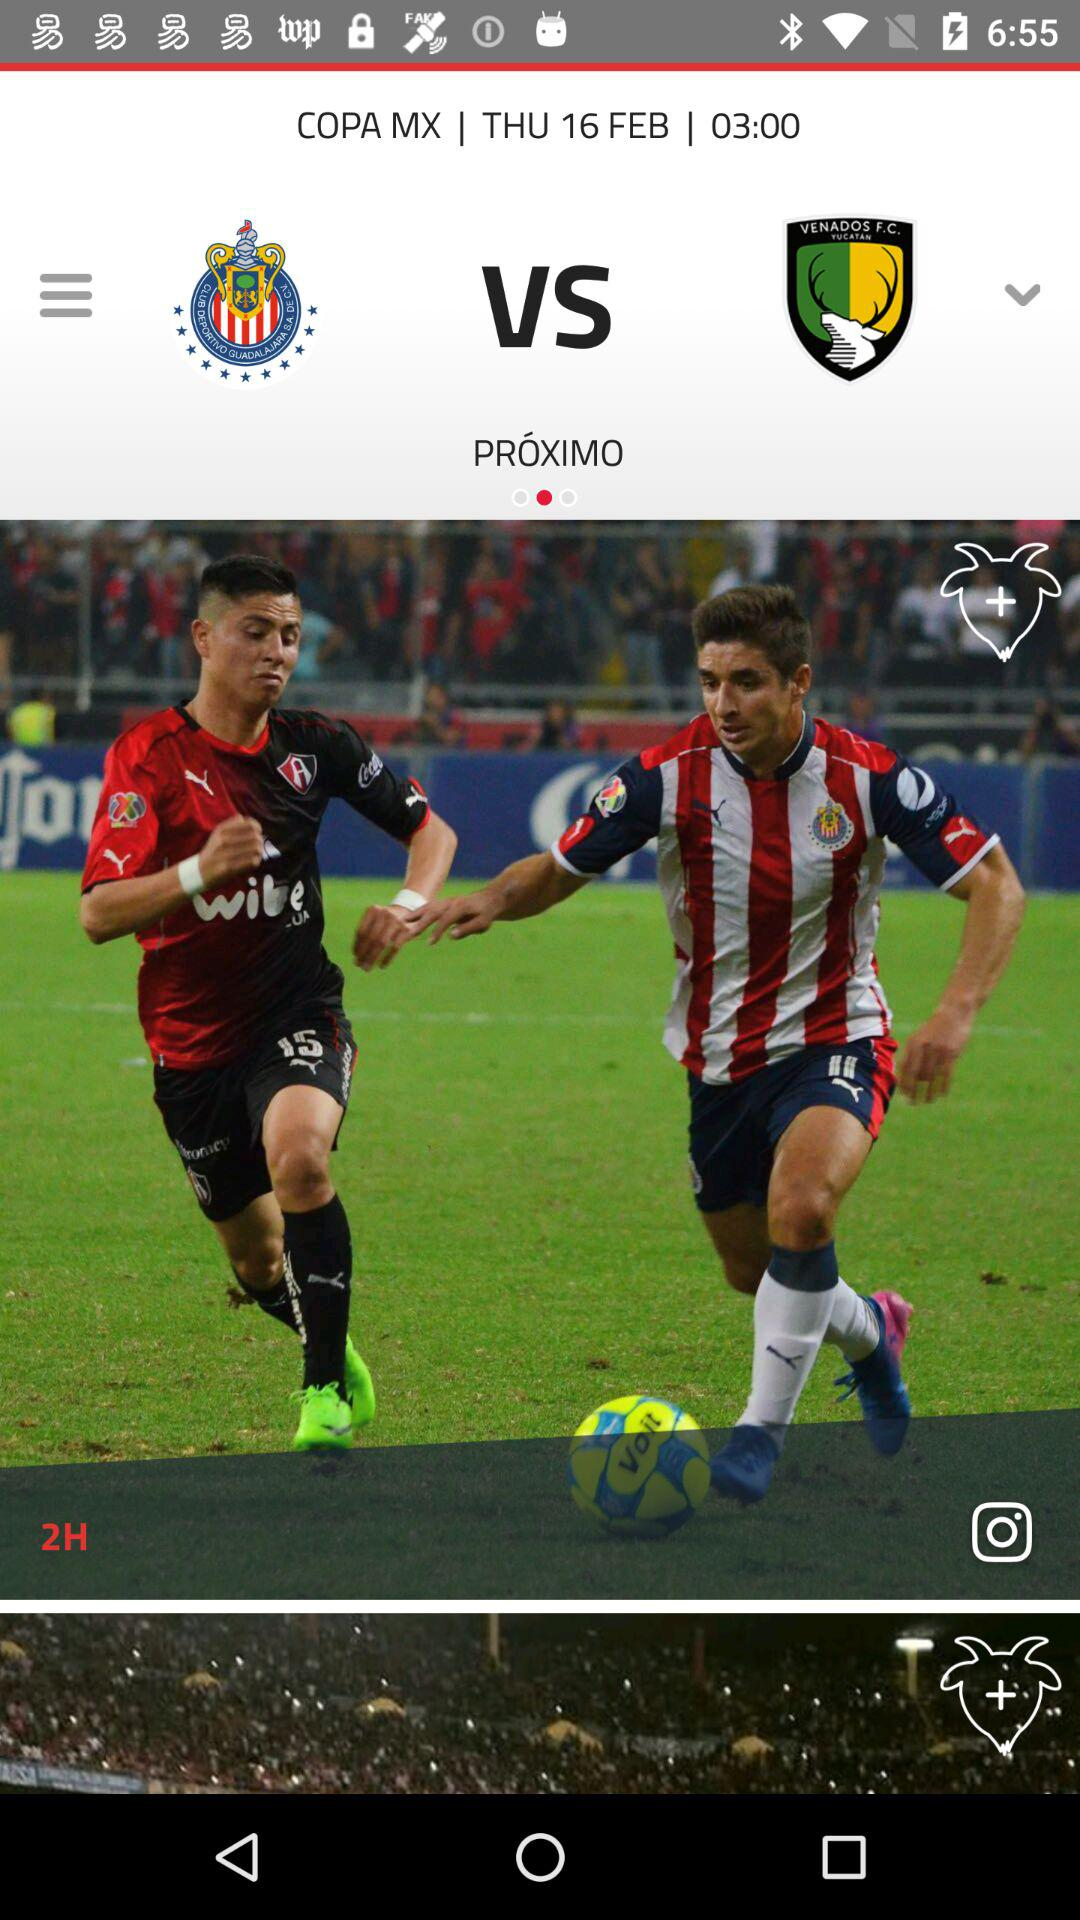How many different teams are playing?
Answer the question using a single word or phrase. 2 